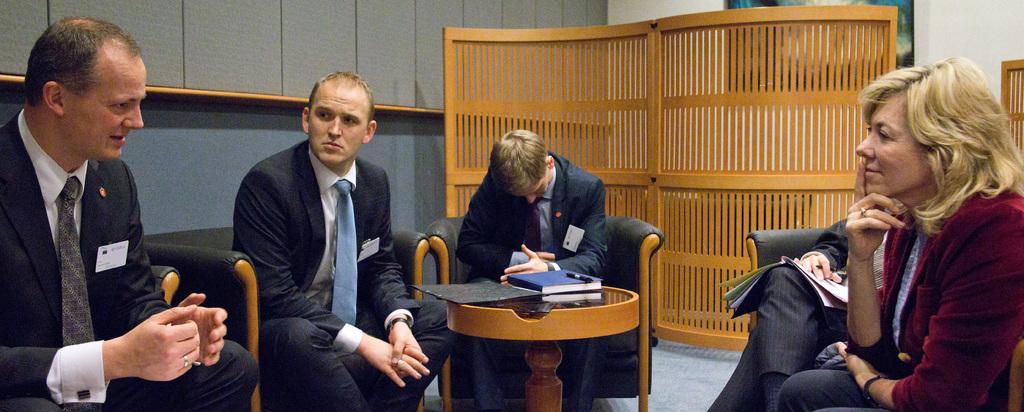What are the people in the image doing? The people in the image are sitting on chairs. What can be seen on the table in the image? There is a book and a pen on the table. Can you describe the object on the table? Unfortunately, the object on the table is not described in the provided facts. What is visible on the wall in the background? There is a frame on the wall in the background. What type of objects can be seen in the background? There are wooden objects in the background. What type of animals can be seen at the zoo in the image? There is no mention of a zoo or any animals in the image. The image features people sitting on chairs, a book and pen on a table, a frame on the wall, and wooden objects in the background. 